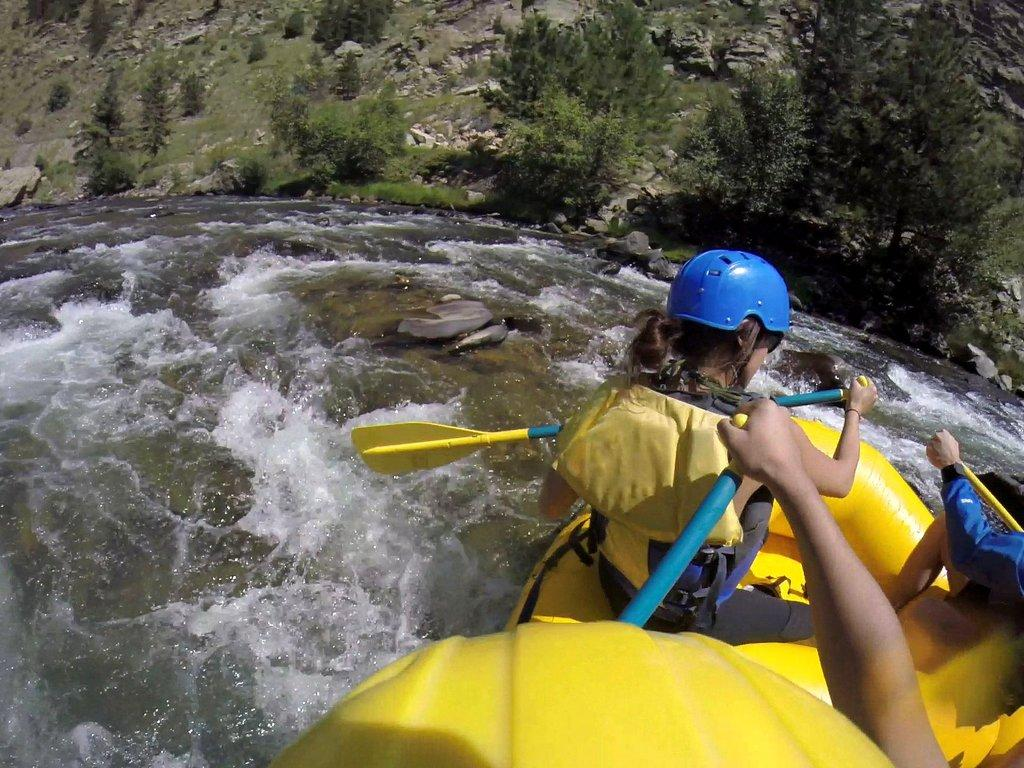What is the person in the image doing? The person in the image is rowing a boat. Where is the boat located? The boat is on the water. What other objects or features can be seen in the image? There are stones, trees, and plants visible in the image. How many bees can be seen flying around the person rowing the boat in the image? There are no bees visible in the image. 